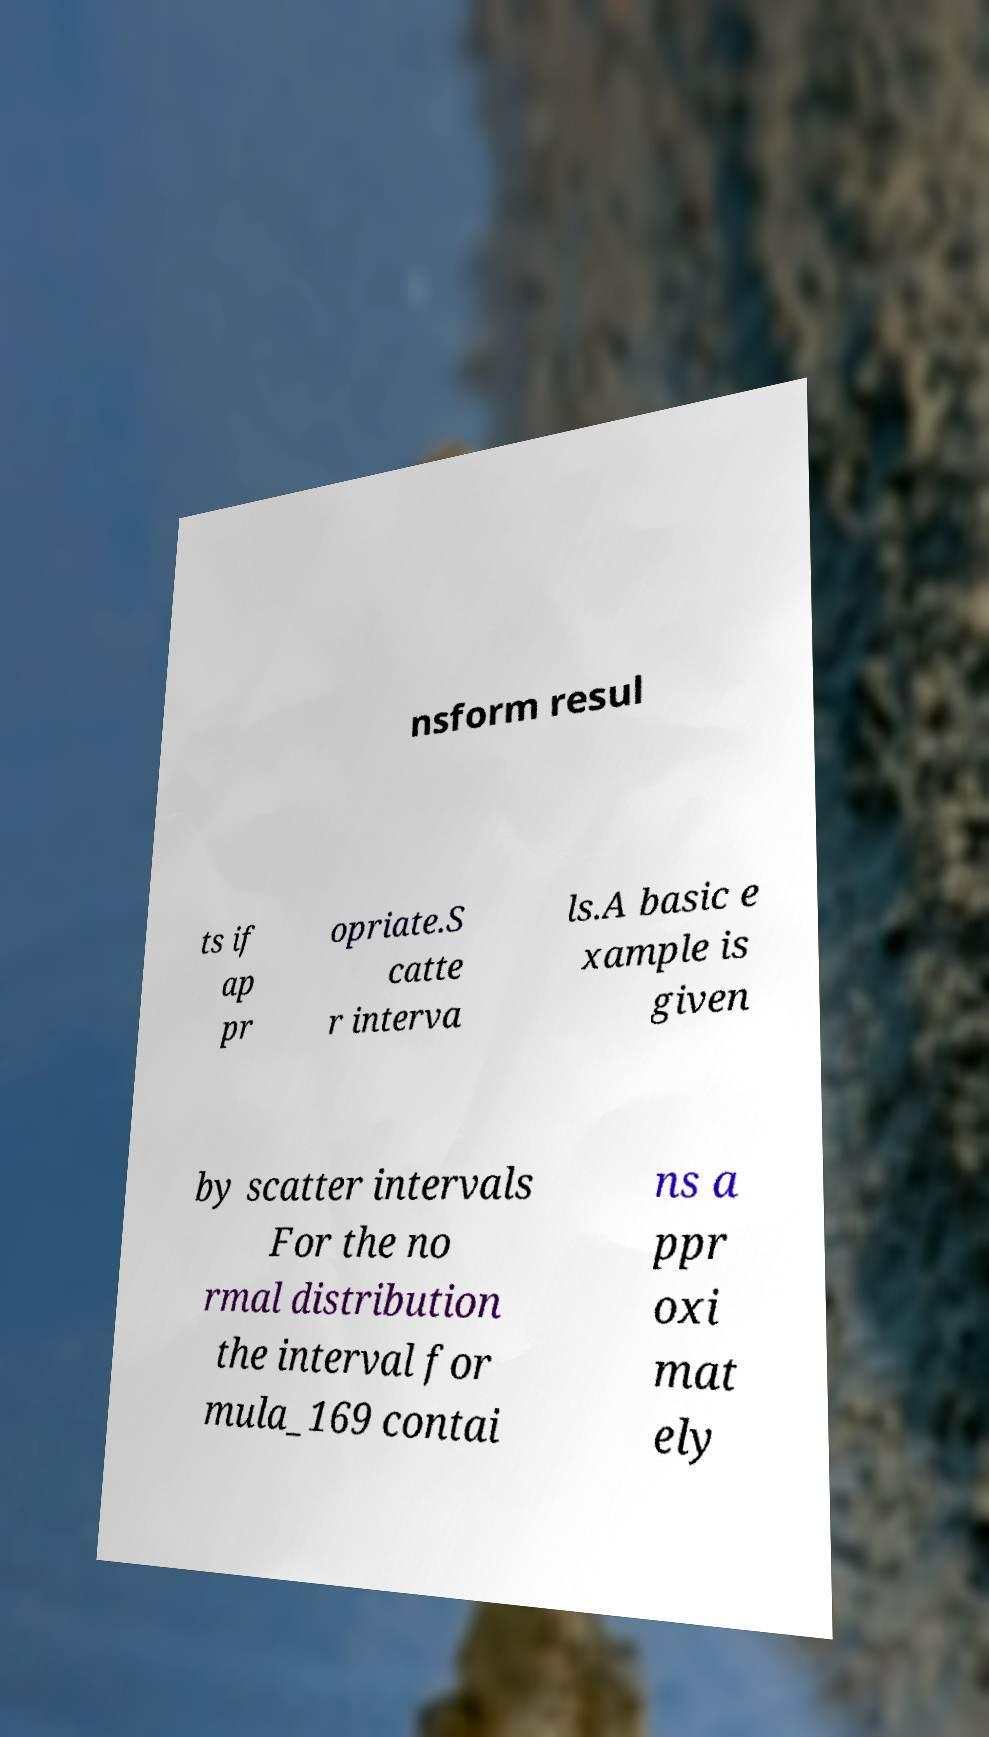Can you accurately transcribe the text from the provided image for me? nsform resul ts if ap pr opriate.S catte r interva ls.A basic e xample is given by scatter intervals For the no rmal distribution the interval for mula_169 contai ns a ppr oxi mat ely 